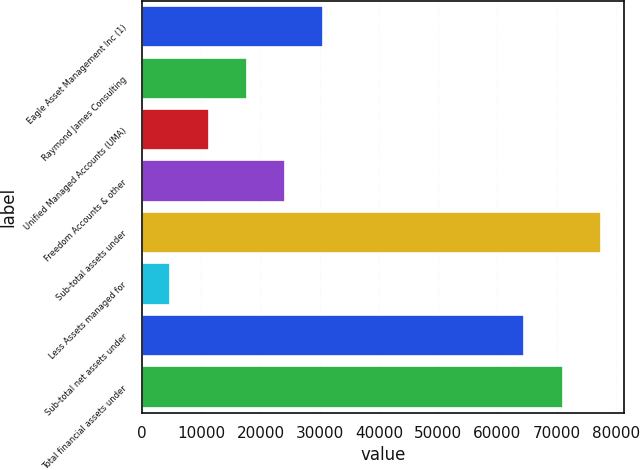Convert chart. <chart><loc_0><loc_0><loc_500><loc_500><bar_chart><fcel>Eagle Asset Management Inc (1)<fcel>Raymond James Consulting<fcel>Unified Managed Accounts (UMA)<fcel>Freedom Accounts & other<fcel>Sub-total assets under<fcel>Less Assets managed for<fcel>Sub-total net assets under<fcel>Total financial assets under<nl><fcel>30633.8<fcel>17722.4<fcel>11266.7<fcel>24178.1<fcel>77468.4<fcel>4811<fcel>64557<fcel>71012.7<nl></chart> 